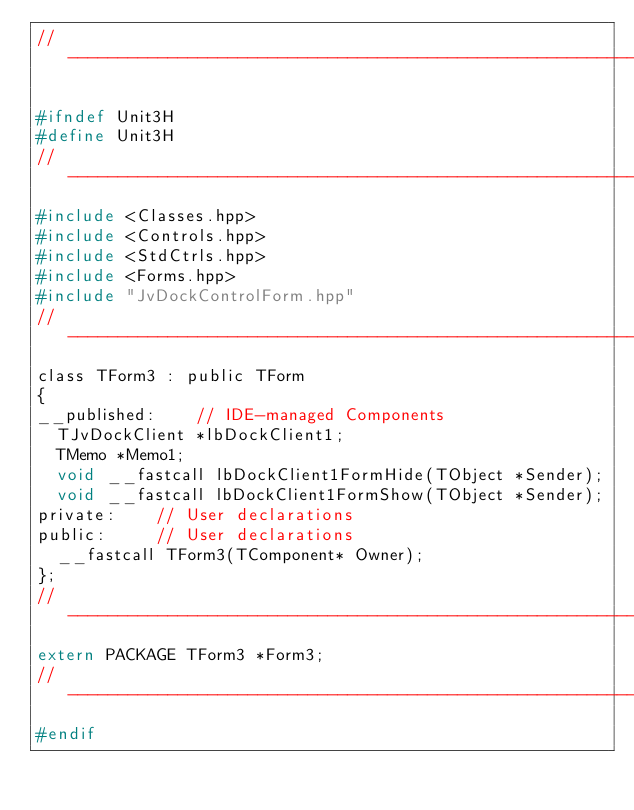Convert code to text. <code><loc_0><loc_0><loc_500><loc_500><_C_>//---------------------------------------------------------------------------

#ifndef Unit3H
#define Unit3H
//---------------------------------------------------------------------------
#include <Classes.hpp>
#include <Controls.hpp>
#include <StdCtrls.hpp>
#include <Forms.hpp>
#include "JvDockControlForm.hpp"
//---------------------------------------------------------------------------
class TForm3 : public TForm
{
__published:	// IDE-managed Components
  TJvDockClient *lbDockClient1;
  TMemo *Memo1;
  void __fastcall lbDockClient1FormHide(TObject *Sender);
  void __fastcall lbDockClient1FormShow(TObject *Sender);
private:	// User declarations
public:		// User declarations
  __fastcall TForm3(TComponent* Owner);
};
//---------------------------------------------------------------------------
extern PACKAGE TForm3 *Form3;
//---------------------------------------------------------------------------
#endif
</code> 